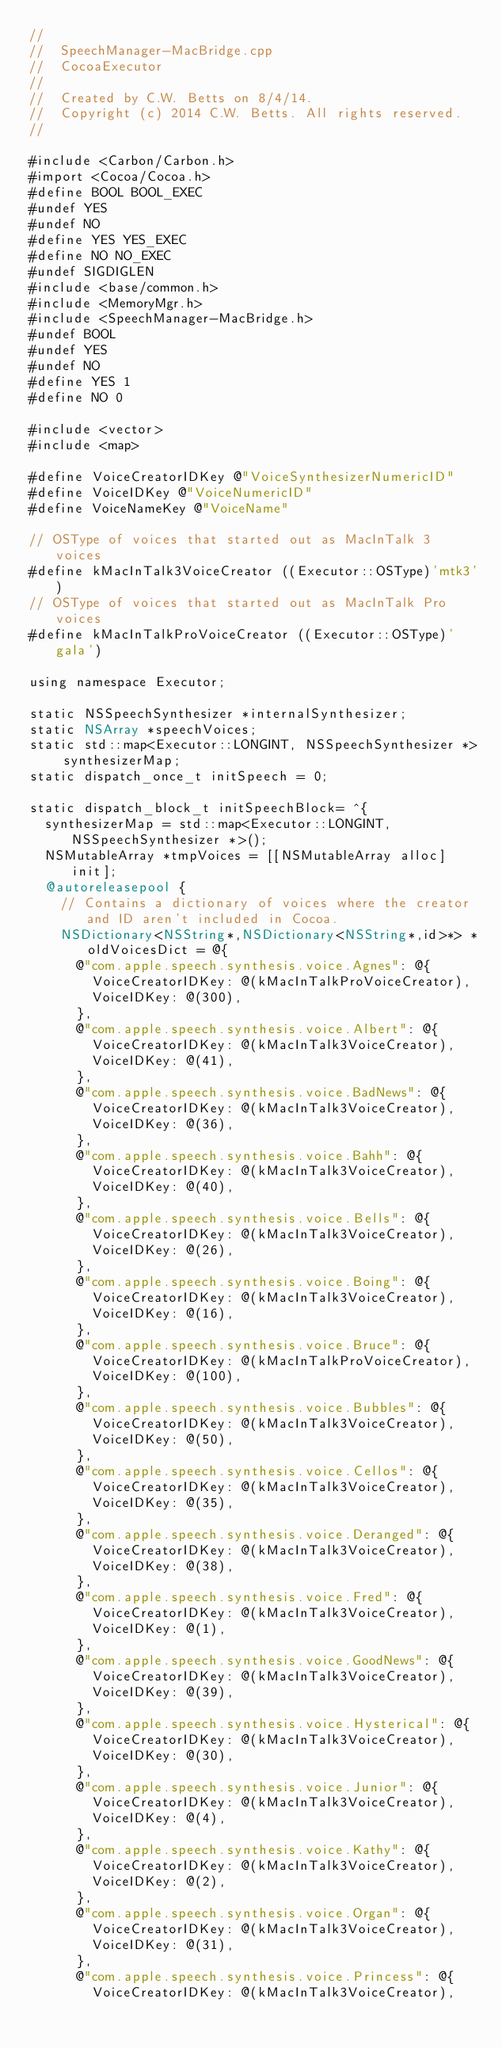<code> <loc_0><loc_0><loc_500><loc_500><_ObjectiveC_>//
//  SpeechManager-MacBridge.cpp
//  CocoaExecutor
//
//  Created by C.W. Betts on 8/4/14.
//  Copyright (c) 2014 C.W. Betts. All rights reserved.
//

#include <Carbon/Carbon.h>
#import <Cocoa/Cocoa.h>
#define BOOL BOOL_EXEC
#undef YES
#undef NO
#define YES YES_EXEC
#define NO NO_EXEC
#undef SIGDIGLEN
#include <base/common.h>
#include <MemoryMgr.h>
#include <SpeechManager-MacBridge.h>
#undef BOOL
#undef YES
#undef NO
#define YES 1
#define NO 0

#include <vector>
#include <map>

#define VoiceCreatorIDKey @"VoiceSynthesizerNumericID"
#define VoiceIDKey @"VoiceNumericID"
#define VoiceNameKey @"VoiceName"

// OSType of voices that started out as MacInTalk 3 voices
#define kMacInTalk3VoiceCreator ((Executor::OSType)'mtk3')
// OSType of voices that started out as MacInTalk Pro voices
#define kMacInTalkProVoiceCreator ((Executor::OSType)'gala')

using namespace Executor;

static NSSpeechSynthesizer *internalSynthesizer;
static NSArray *speechVoices;
static std::map<Executor::LONGINT, NSSpeechSynthesizer *> synthesizerMap;
static dispatch_once_t initSpeech = 0;

static dispatch_block_t initSpeechBlock= ^{
  synthesizerMap = std::map<Executor::LONGINT, NSSpeechSynthesizer *>();
  NSMutableArray *tmpVoices = [[NSMutableArray alloc] init];
  @autoreleasepool {
    // Contains a dictionary of voices where the creator and ID aren't included in Cocoa.
    NSDictionary<NSString*,NSDictionary<NSString*,id>*> *oldVoicesDict = @{
      @"com.apple.speech.synthesis.voice.Agnes": @{
        VoiceCreatorIDKey: @(kMacInTalkProVoiceCreator),
        VoiceIDKey: @(300),
      },
      @"com.apple.speech.synthesis.voice.Albert": @{
        VoiceCreatorIDKey: @(kMacInTalk3VoiceCreator),
        VoiceIDKey: @(41),
      },
      @"com.apple.speech.synthesis.voice.BadNews": @{
        VoiceCreatorIDKey: @(kMacInTalk3VoiceCreator),
        VoiceIDKey: @(36),
      },
      @"com.apple.speech.synthesis.voice.Bahh": @{
        VoiceCreatorIDKey: @(kMacInTalk3VoiceCreator),
        VoiceIDKey: @(40),
      },
      @"com.apple.speech.synthesis.voice.Bells": @{
        VoiceCreatorIDKey: @(kMacInTalk3VoiceCreator),
        VoiceIDKey: @(26),
      },
      @"com.apple.speech.synthesis.voice.Boing": @{
        VoiceCreatorIDKey: @(kMacInTalk3VoiceCreator),
        VoiceIDKey: @(16),
      },
      @"com.apple.speech.synthesis.voice.Bruce": @{
        VoiceCreatorIDKey: @(kMacInTalkProVoiceCreator),
        VoiceIDKey: @(100),
      },
      @"com.apple.speech.synthesis.voice.Bubbles": @{
        VoiceCreatorIDKey: @(kMacInTalk3VoiceCreator),
        VoiceIDKey: @(50),
      },
      @"com.apple.speech.synthesis.voice.Cellos": @{
        VoiceCreatorIDKey: @(kMacInTalk3VoiceCreator),
        VoiceIDKey: @(35),
      },
      @"com.apple.speech.synthesis.voice.Deranged": @{
        VoiceCreatorIDKey: @(kMacInTalk3VoiceCreator),
        VoiceIDKey: @(38),
      },
      @"com.apple.speech.synthesis.voice.Fred": @{
        VoiceCreatorIDKey: @(kMacInTalk3VoiceCreator),
        VoiceIDKey: @(1),
      },
      @"com.apple.speech.synthesis.voice.GoodNews": @{
        VoiceCreatorIDKey: @(kMacInTalk3VoiceCreator),
        VoiceIDKey: @(39),
      },
      @"com.apple.speech.synthesis.voice.Hysterical": @{
        VoiceCreatorIDKey: @(kMacInTalk3VoiceCreator),
        VoiceIDKey: @(30),
      },
      @"com.apple.speech.synthesis.voice.Junior": @{
        VoiceCreatorIDKey: @(kMacInTalk3VoiceCreator),
        VoiceIDKey: @(4),
      },
      @"com.apple.speech.synthesis.voice.Kathy": @{
        VoiceCreatorIDKey: @(kMacInTalk3VoiceCreator),
        VoiceIDKey: @(2),
      },
      @"com.apple.speech.synthesis.voice.Organ": @{
        VoiceCreatorIDKey: @(kMacInTalk3VoiceCreator),
        VoiceIDKey: @(31),
      },
      @"com.apple.speech.synthesis.voice.Princess": @{
        VoiceCreatorIDKey: @(kMacInTalk3VoiceCreator),</code> 